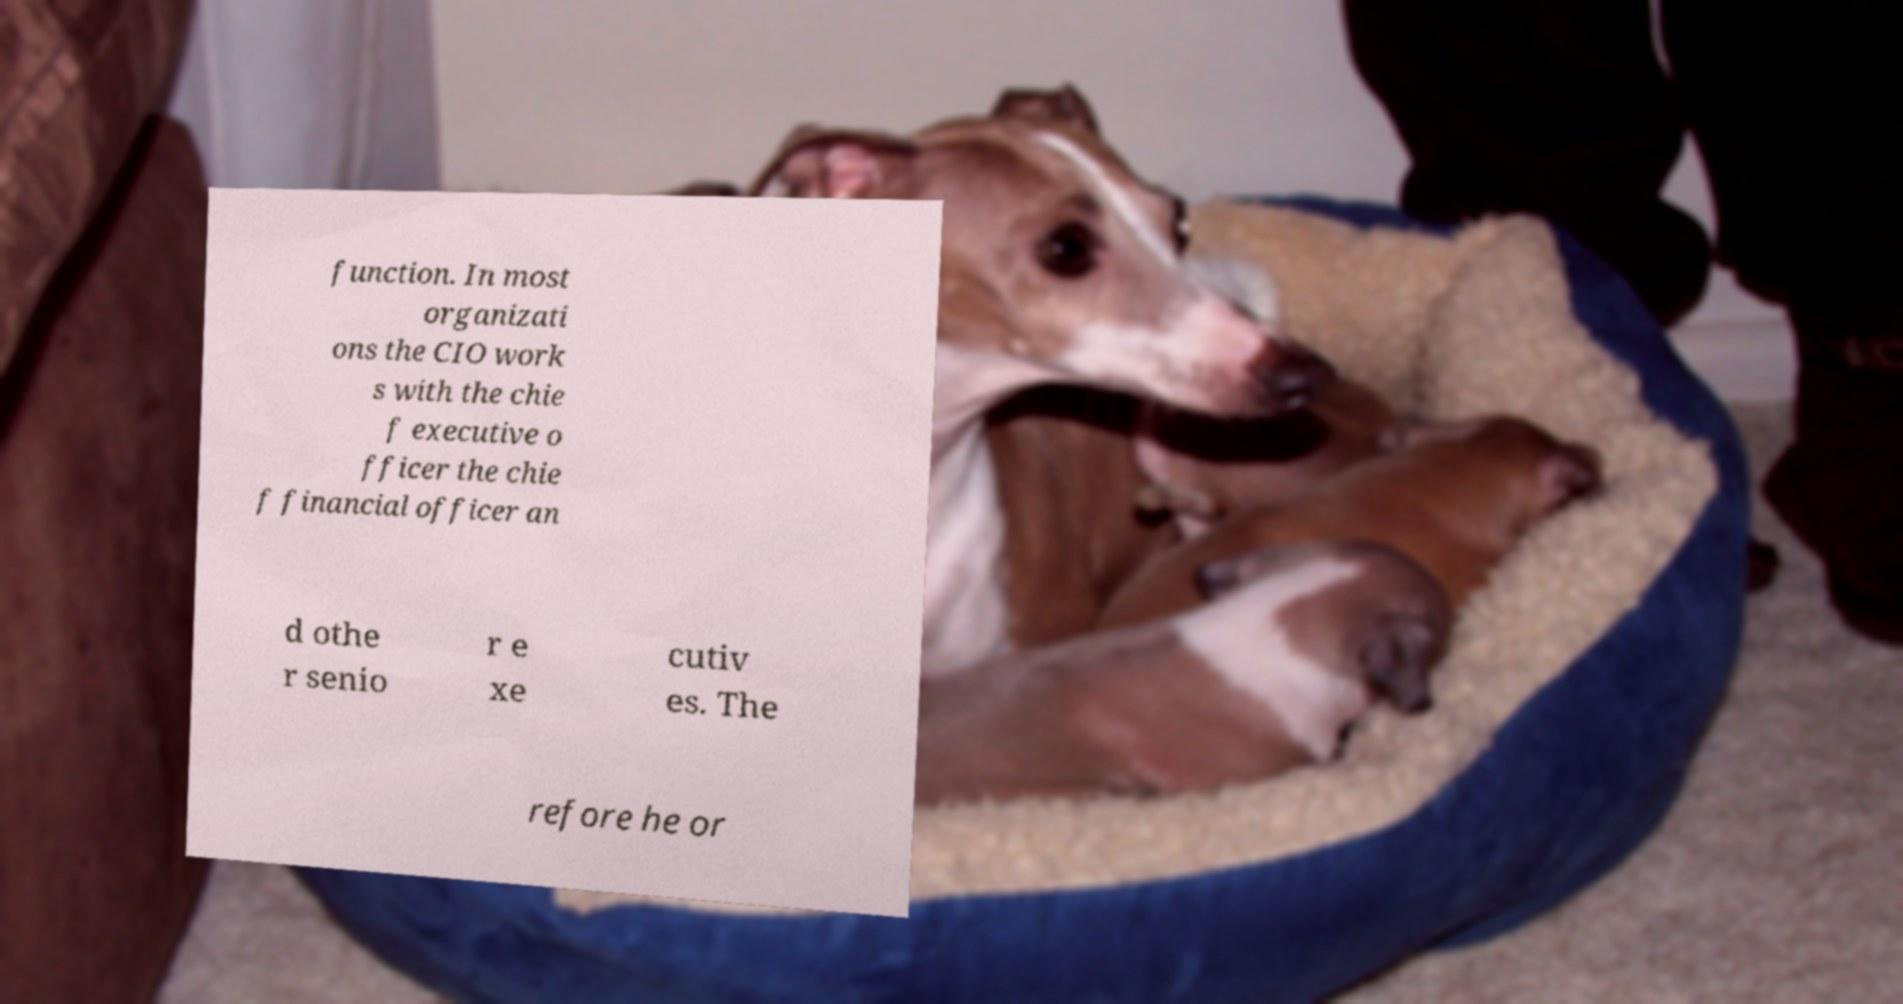For documentation purposes, I need the text within this image transcribed. Could you provide that? function. In most organizati ons the CIO work s with the chie f executive o fficer the chie f financial officer an d othe r senio r e xe cutiv es. The refore he or 